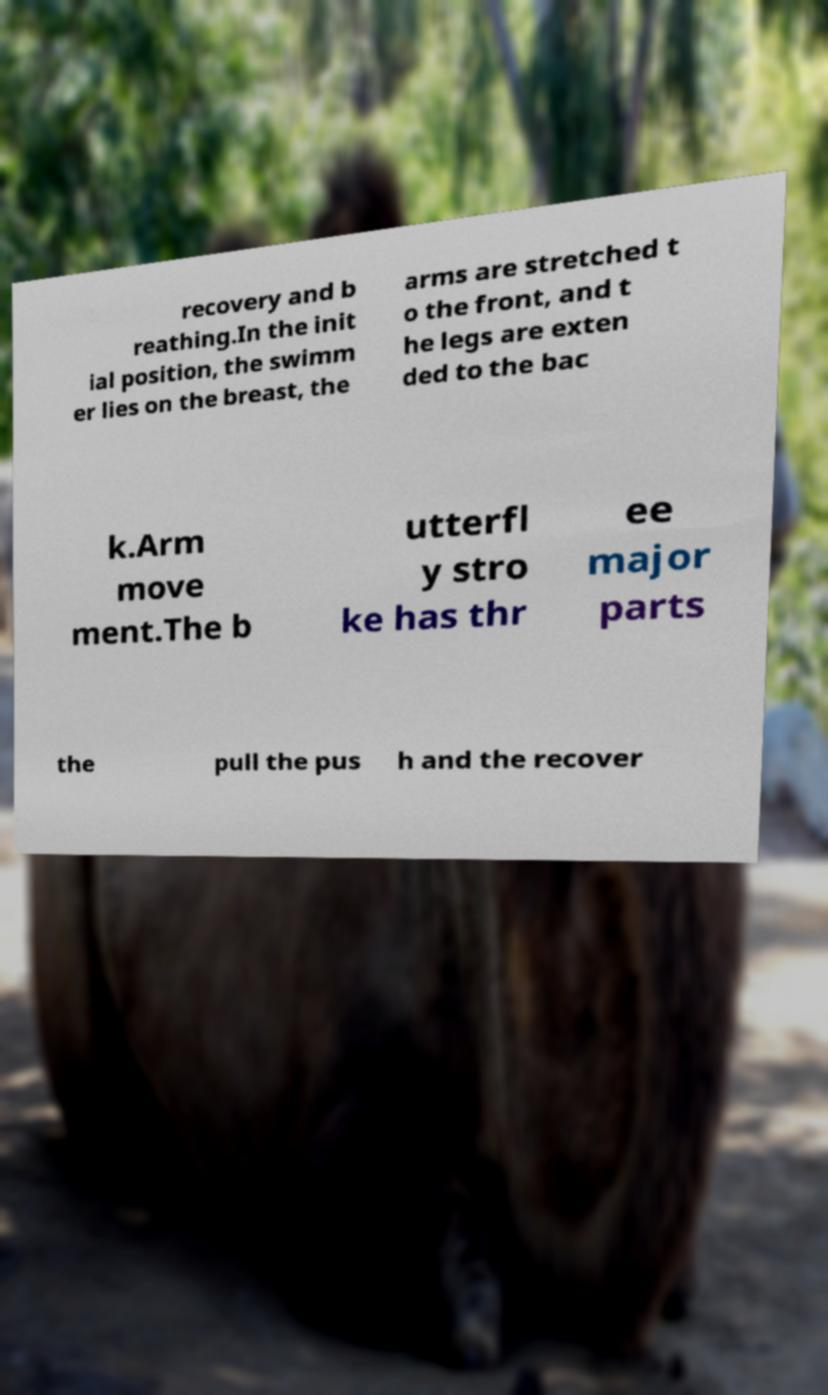I need the written content from this picture converted into text. Can you do that? recovery and b reathing.In the init ial position, the swimm er lies on the breast, the arms are stretched t o the front, and t he legs are exten ded to the bac k.Arm move ment.The b utterfl y stro ke has thr ee major parts the pull the pus h and the recover 